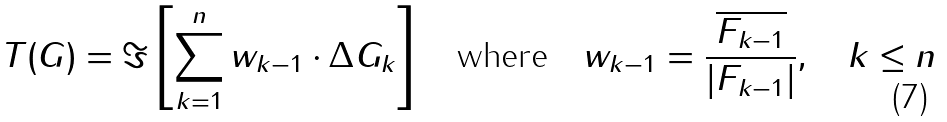<formula> <loc_0><loc_0><loc_500><loc_500>T ( G ) = \Im \left [ \sum _ { k = 1 } ^ { n } w _ { k - 1 } \cdot \Delta G _ { k } \right ] \quad \text {where} \quad w _ { k - 1 } = \frac { \overline { F _ { k - 1 } } } { | F _ { k - 1 } | } , \quad k \leq n</formula> 